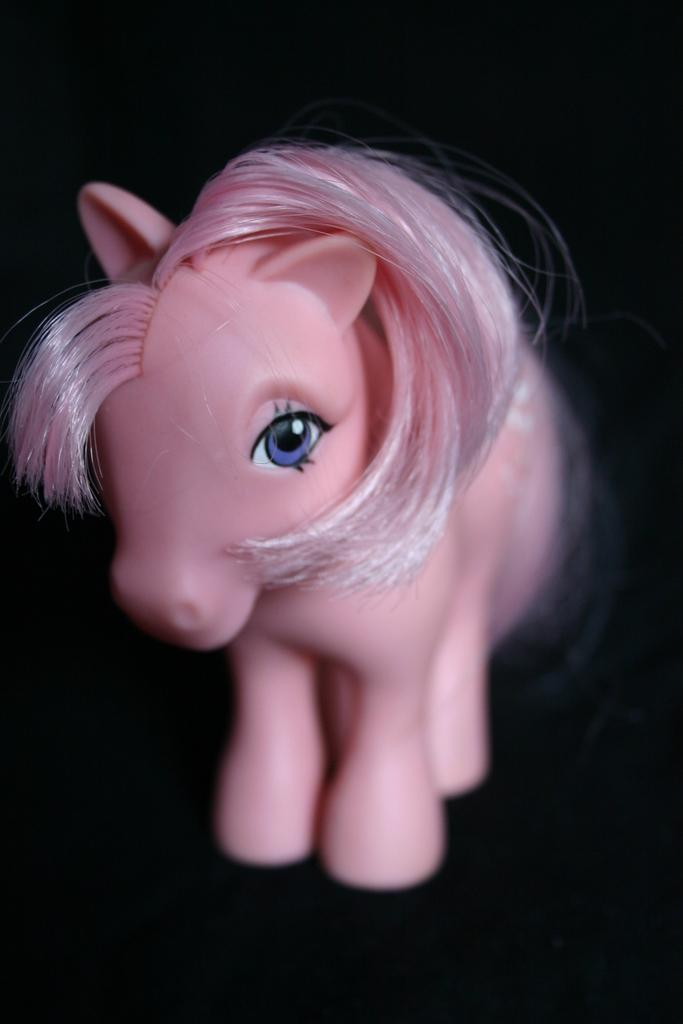What object can be seen in the image? There is a toy in the image. Where is the toy located? The toy is placed on a surface. What type of bone can be seen in the image? There is no bone present in the image; it features a toy placed on a surface. How many kernels of corn can be counted in the image? There is no corn present in the image. 